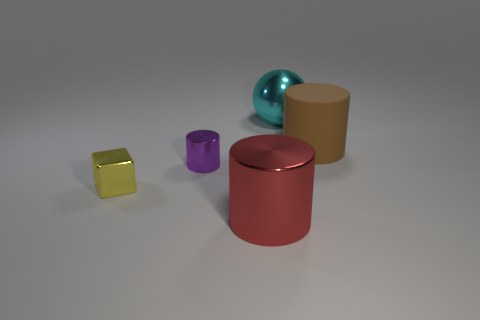Are there any other things that are the same material as the brown cylinder?
Your answer should be compact. No. What material is the big brown cylinder?
Your answer should be very brief. Rubber. What number of cylinders are large things or brown rubber objects?
Ensure brevity in your answer.  2. Are the purple thing and the large brown thing made of the same material?
Your answer should be very brief. No. What is the size of the matte object that is the same shape as the large red metallic object?
Make the answer very short. Large. What is the material of the cylinder that is to the right of the tiny purple object and behind the small yellow shiny thing?
Offer a terse response. Rubber. Are there an equal number of brown matte things to the left of the big matte object and tiny cylinders?
Offer a very short reply. No. How many things are either things to the left of the big red shiny object or cyan rubber things?
Give a very brief answer. 2. There is a metallic thing that is in front of the small yellow object; what size is it?
Your response must be concise. Large. The small metal object that is right of the yellow shiny block on the left side of the large metal ball is what shape?
Ensure brevity in your answer.  Cylinder. 